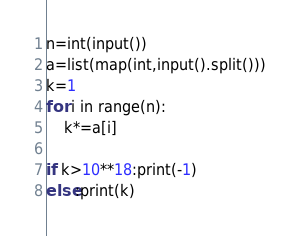Convert code to text. <code><loc_0><loc_0><loc_500><loc_500><_Python_>n=int(input())
a=list(map(int,input().split()))
k=1
for i in range(n):
    k*=a[i]

if k>10**18:print(-1)
else:print(k)</code> 